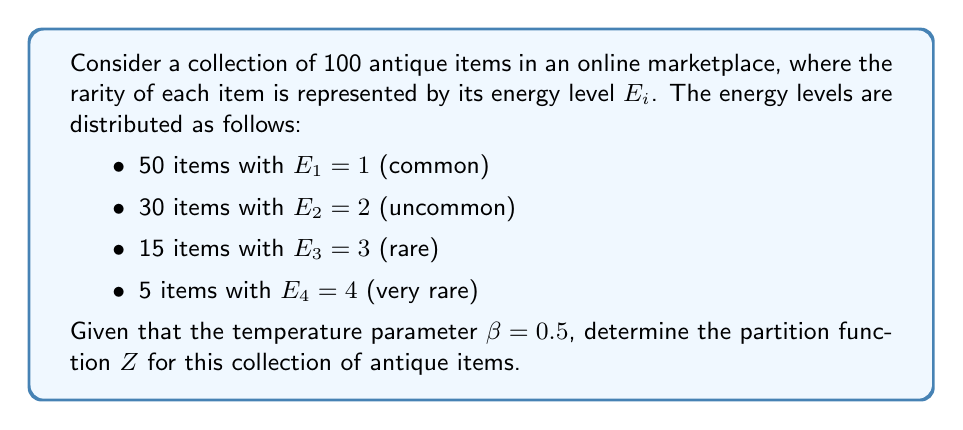What is the answer to this math problem? To solve this problem, we'll follow these steps:

1) The partition function $Z$ is given by the sum of Boltzmann factors over all possible states:

   $$Z = \sum_i g_i e^{-\beta E_i}$$

   where $g_i$ is the degeneracy (number of items) for each energy level $E_i$.

2) We have four energy levels, so we'll calculate the Boltzmann factor for each:

   For $E_1 = 1$: $g_1 = 50$, $e^{-\beta E_1} = e^{-0.5 \cdot 1} = e^{-0.5}$
   For $E_2 = 2$: $g_2 = 30$, $e^{-\beta E_2} = e^{-0.5 \cdot 2} = e^{-1}$
   For $E_3 = 3$: $g_3 = 15$, $e^{-\beta E_3} = e^{-0.5 \cdot 3} = e^{-1.5}$
   For $E_4 = 4$: $g_4 = 5$,  $e^{-\beta E_4} = e^{-0.5 \cdot 4} = e^{-2}$

3) Now, we sum these terms:

   $$Z = 50e^{-0.5} + 30e^{-1} + 15e^{-1.5} + 5e^{-2}$$

4) We can simplify this using the properties of exponents:

   $$Z = 50e^{-0.5} + 30e^{-1} + 15e^{-1.5} + 5e^{-2}$$
   $$= 50e^{-0.5} + 30(e^{-0.5})^2 + 15(e^{-0.5})^3 + 5(e^{-0.5})^4$$

5) Let $x = e^{-0.5}$. Then our equation becomes:

   $$Z = 50x + 30x^2 + 15x^3 + 5x^4$$

This is the final form of our partition function.
Answer: $Z = 50e^{-0.5} + 30e^{-1} + 15e^{-1.5} + 5e^{-2}$ 